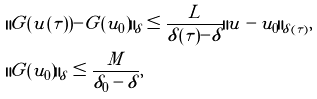Convert formula to latex. <formula><loc_0><loc_0><loc_500><loc_500>& \| G ( u ( \tau ) ) - G ( u _ { 0 } ) \| _ { \delta } \leq \frac { L } { \delta ( \tau ) - \delta } \| u - u _ { 0 } \| _ { \delta ( \tau ) } , \\ & \| G ( u _ { 0 } ) \| _ { \delta } \leq \frac { M } { \delta _ { 0 } - \delta } ,</formula> 